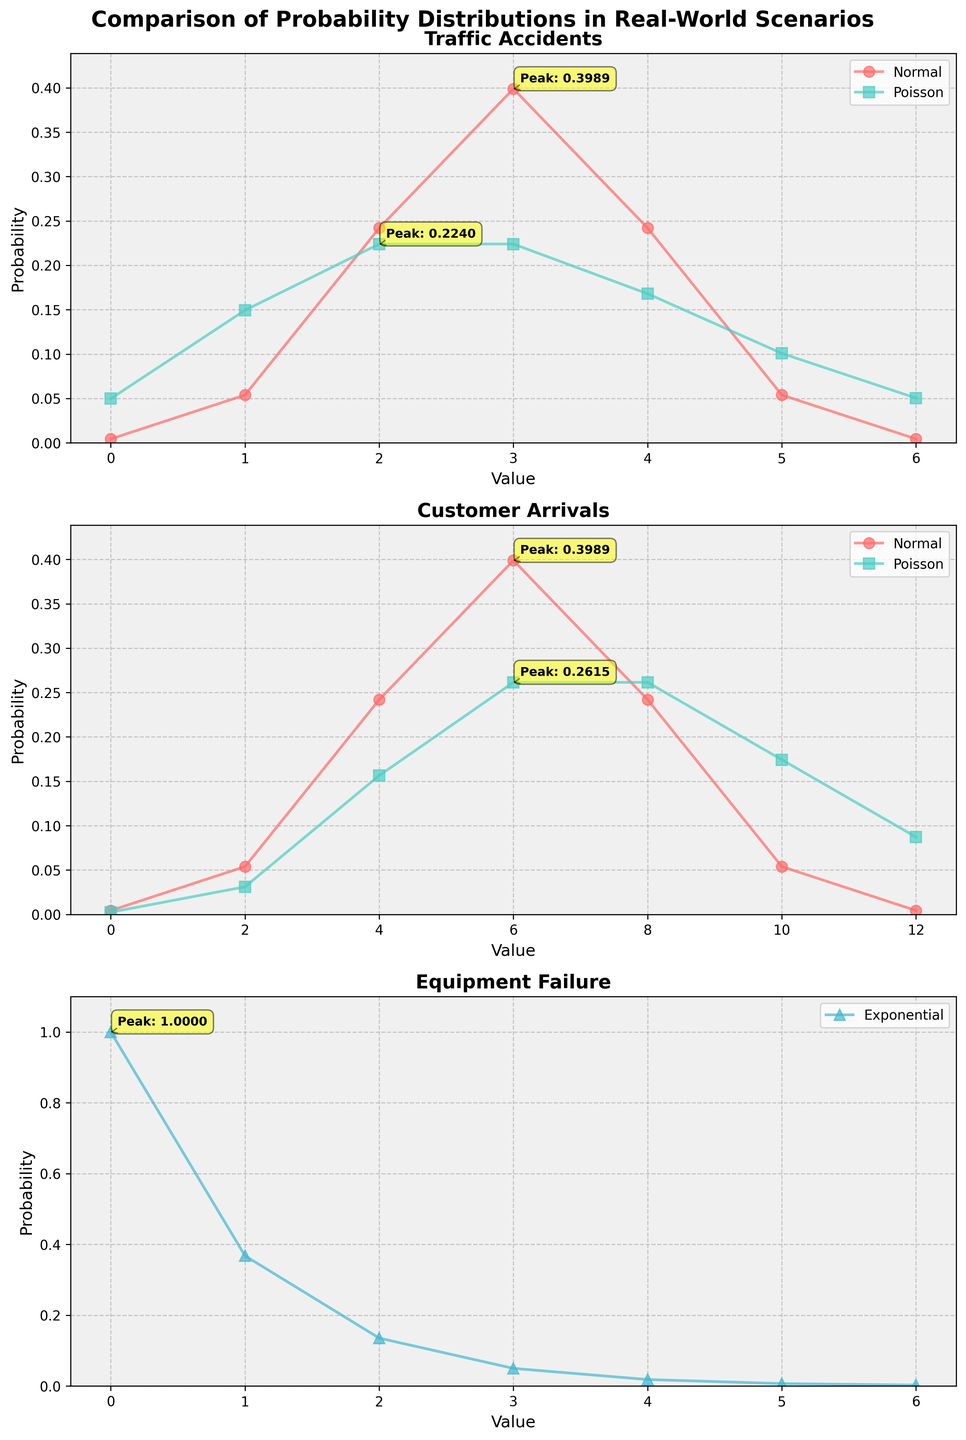What are the peak probabilities for the Normal and Poisson distributions in the "Traffic Accidents" scenario? To find the peak probabilities, we look for the highest y-values for both distributions in the "Traffic Accidents" scenario. For the Normal distribution, the peak value is at x=3 with a probability of 0.3989. For the Poisson distribution, the peak value is at x=2 and x=3 both with a probability of 0.2240.
Answer: 0.3989 (Normal) and 0.2240 (Poisson) Which distribution has a higher peak probability in the "Equipment Failure" scenario? The "Equipment Failure" scenario only has data for the Exponential distribution. The peak probability is at x=0 with a value of 1.0000. As there is no other distribution in this scenario, the Exponential distribution has the highest peak probability.
Answer: Exponential For the "Customer Arrivals" scenario, how much higher is the peak probability of the Normal distribution compared to the Poisson distribution? In the "Customer Arrivals" scenario, the peak probability for the Normal distribution is 0.3989 at x=6. The peak probability for the Poisson distribution is 0.2615 also at x=6. The difference is 0.3989 - 0.2615 = 0.1374.
Answer: 0.1374 Which distribution in the "Traffic Accidents" scenario has the smallest probability value and what is it? We need to check the lowest y-values for both Normal and Poisson distributions in "Traffic Accidents". The smallest value for the Normal distribution is 0.0044 at x=0 and x=6. For the Poisson distribution, it is 0.0498 at x=0. Thus, the smallest probability value is 0.0044 from the Normal distribution.
Answer: 0.0044 (Normal) Compare the shapes of the Normal and Poisson distributions in the "Traffic Accidents" scenario. Which one is more symmetric? The Normal distribution forms a symmetric bell-curve centered around x=3. The Poisson distribution is skewed towards the lower values (0, 1, 2) but tails off more gradually. Thus, the Normal distribution is more symmetric.
Answer: Normal Is the peak probability for "Equipment Failure" greater than the combined peak probabilities of the Poisson distributions in both "Traffic Accidents" and "Customer Arrivals"? The peak probability for "Equipment Failure" is 1.0000. The peak probabilities for Poisson distributions in "Traffic Accidents" and "Customer Arrivals" are both 0.2240 and 0.2615, respectively. Summing these gives 0.2240 + 0.2615 = 0.4855. Since 1.0000 > 0.4855, the peak probability for "Equipment Failure" is greater.
Answer: Yes What is the combined maximum probability of all the Normal distributions across all scenarios? For "Traffic Accidents" the peak value for Normal is 0.3989. For "Customer Arrivals", the peak value for Normal is also 0.3989. Adding these gives 0.3989 + 0.3989 = 0.7978.
Answer: 0.7978 